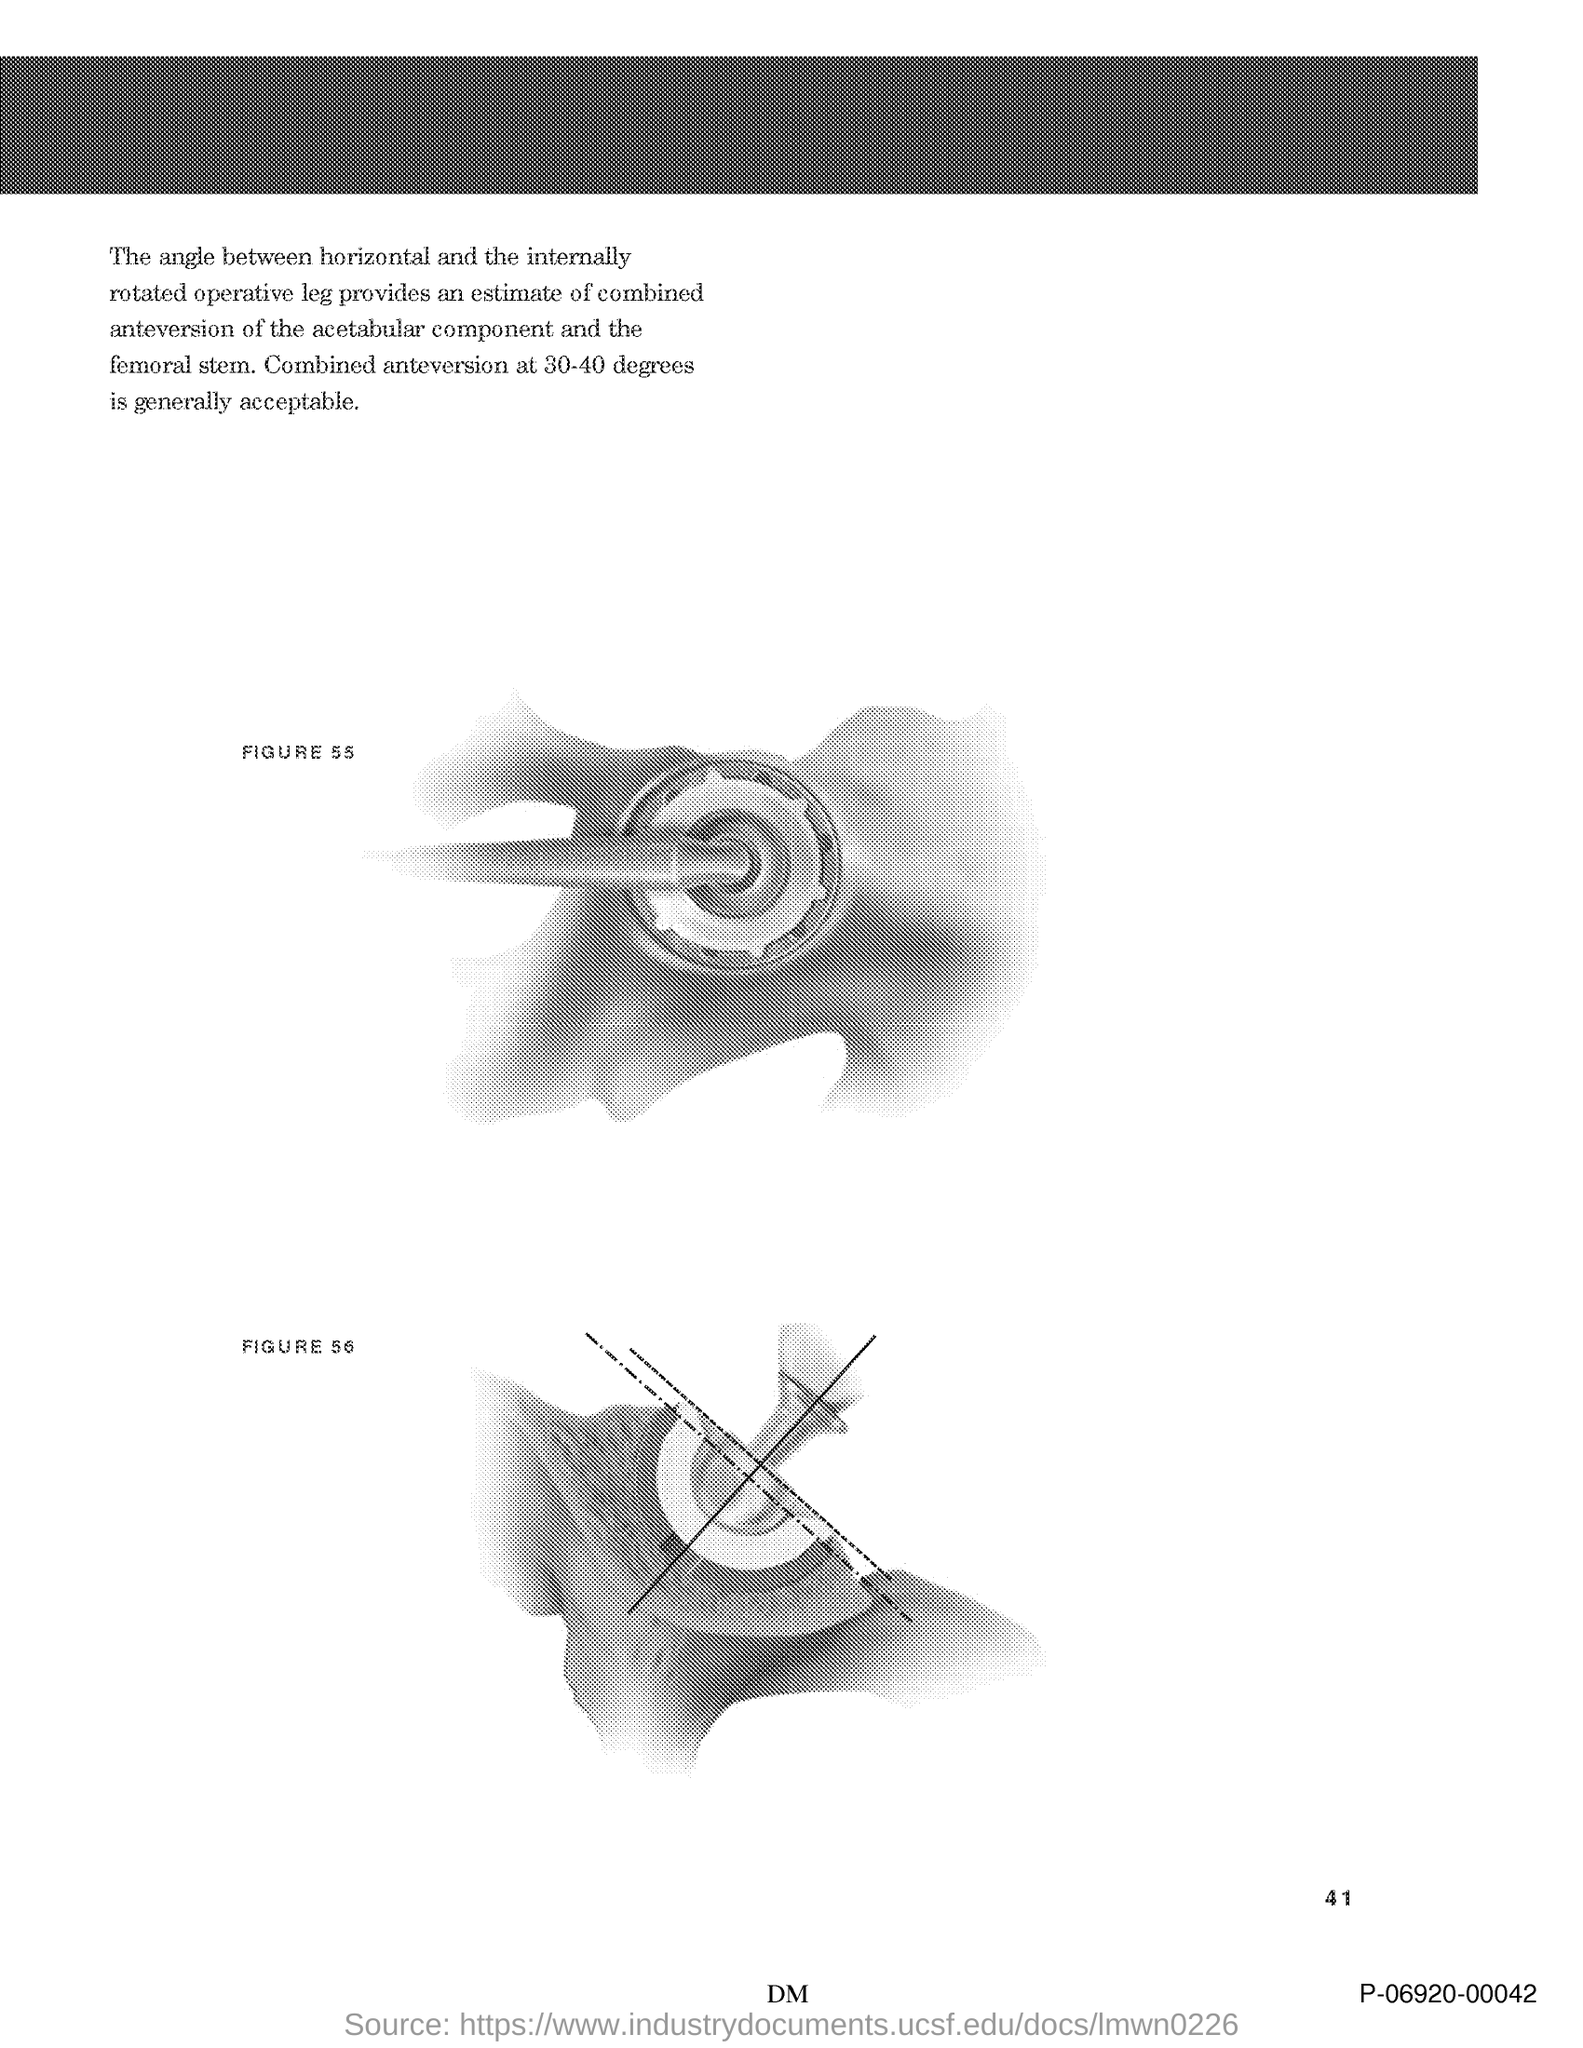What is the Page Number?
Provide a succinct answer. 41. 